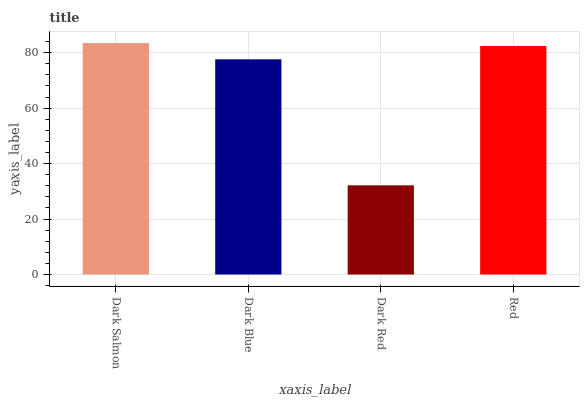Is Dark Red the minimum?
Answer yes or no. Yes. Is Dark Salmon the maximum?
Answer yes or no. Yes. Is Dark Blue the minimum?
Answer yes or no. No. Is Dark Blue the maximum?
Answer yes or no. No. Is Dark Salmon greater than Dark Blue?
Answer yes or no. Yes. Is Dark Blue less than Dark Salmon?
Answer yes or no. Yes. Is Dark Blue greater than Dark Salmon?
Answer yes or no. No. Is Dark Salmon less than Dark Blue?
Answer yes or no. No. Is Red the high median?
Answer yes or no. Yes. Is Dark Blue the low median?
Answer yes or no. Yes. Is Dark Red the high median?
Answer yes or no. No. Is Dark Red the low median?
Answer yes or no. No. 